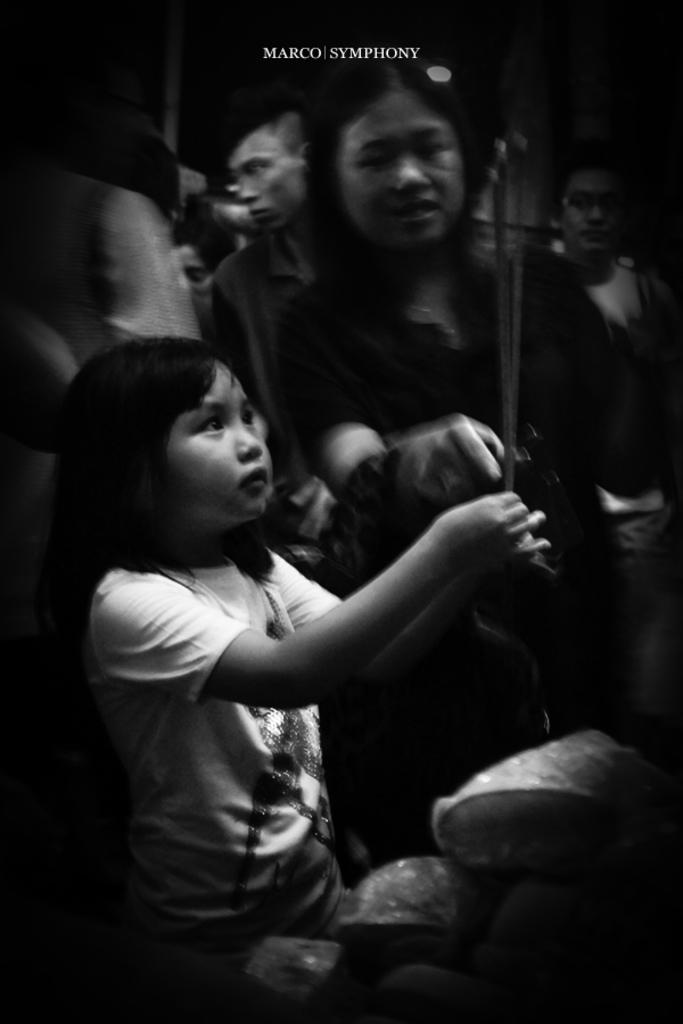Who or what can be seen in the image? There are people in the image. What else is present in the image? There is a watermark in the image. How would you describe the color scheme of the image? The image is black and white in color. What is the taste of the tooth in the image? There is no tooth present in the image, and therefore no taste can be determined. 